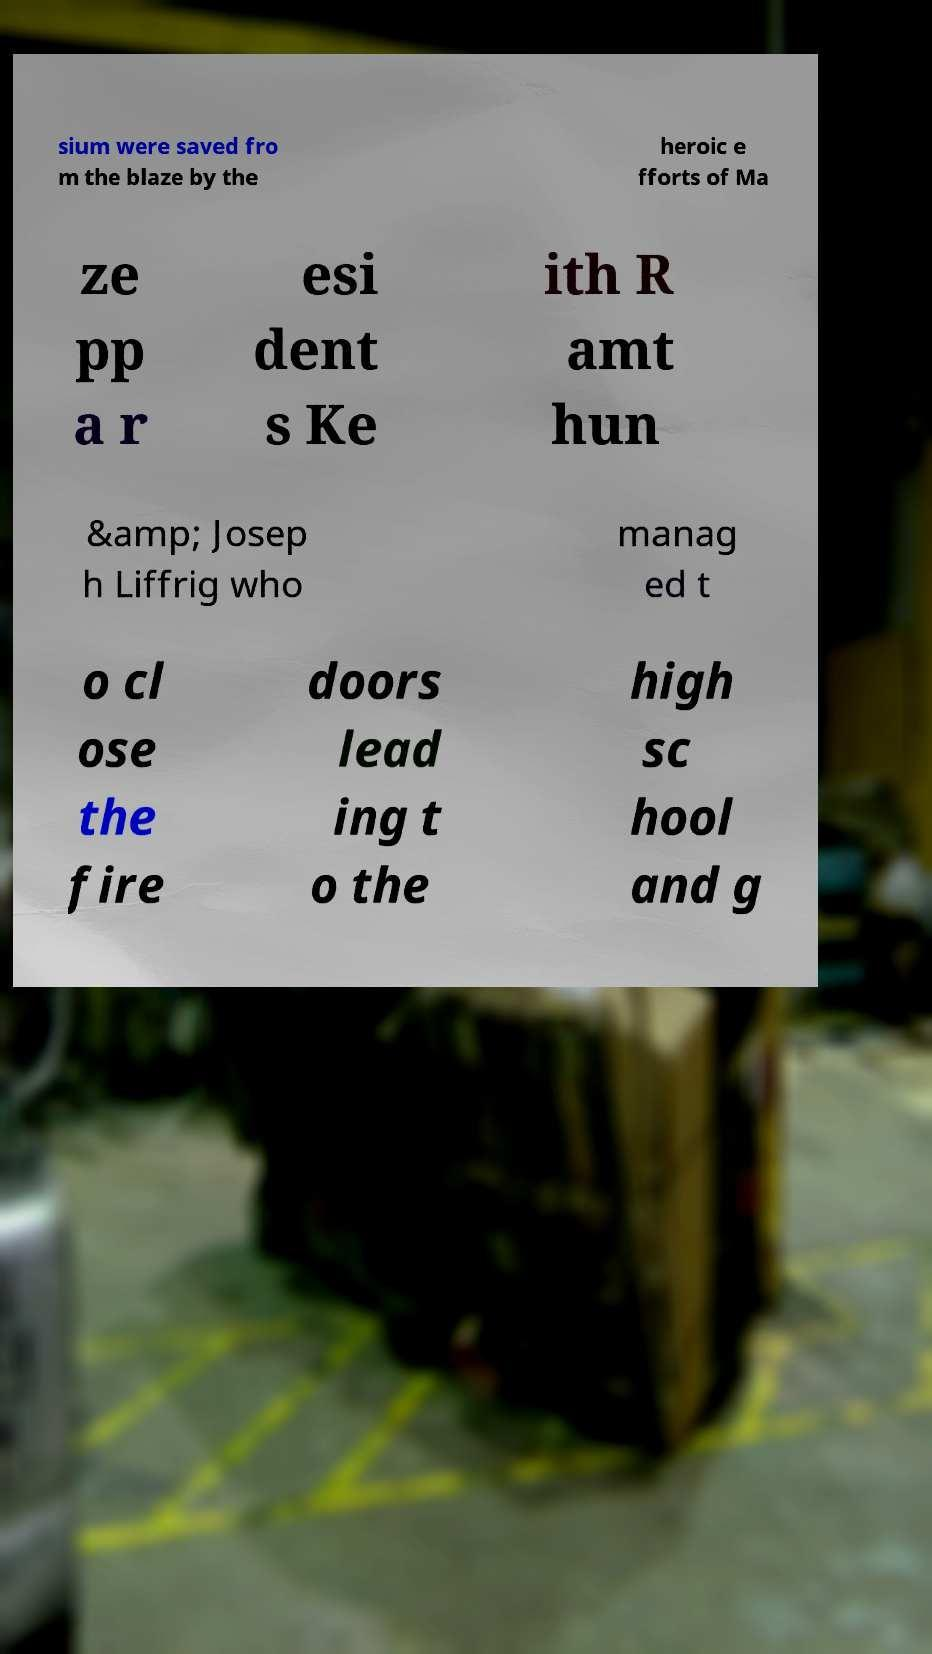I need the written content from this picture converted into text. Can you do that? sium were saved fro m the blaze by the heroic e fforts of Ma ze pp a r esi dent s Ke ith R amt hun &amp; Josep h Liffrig who manag ed t o cl ose the fire doors lead ing t o the high sc hool and g 